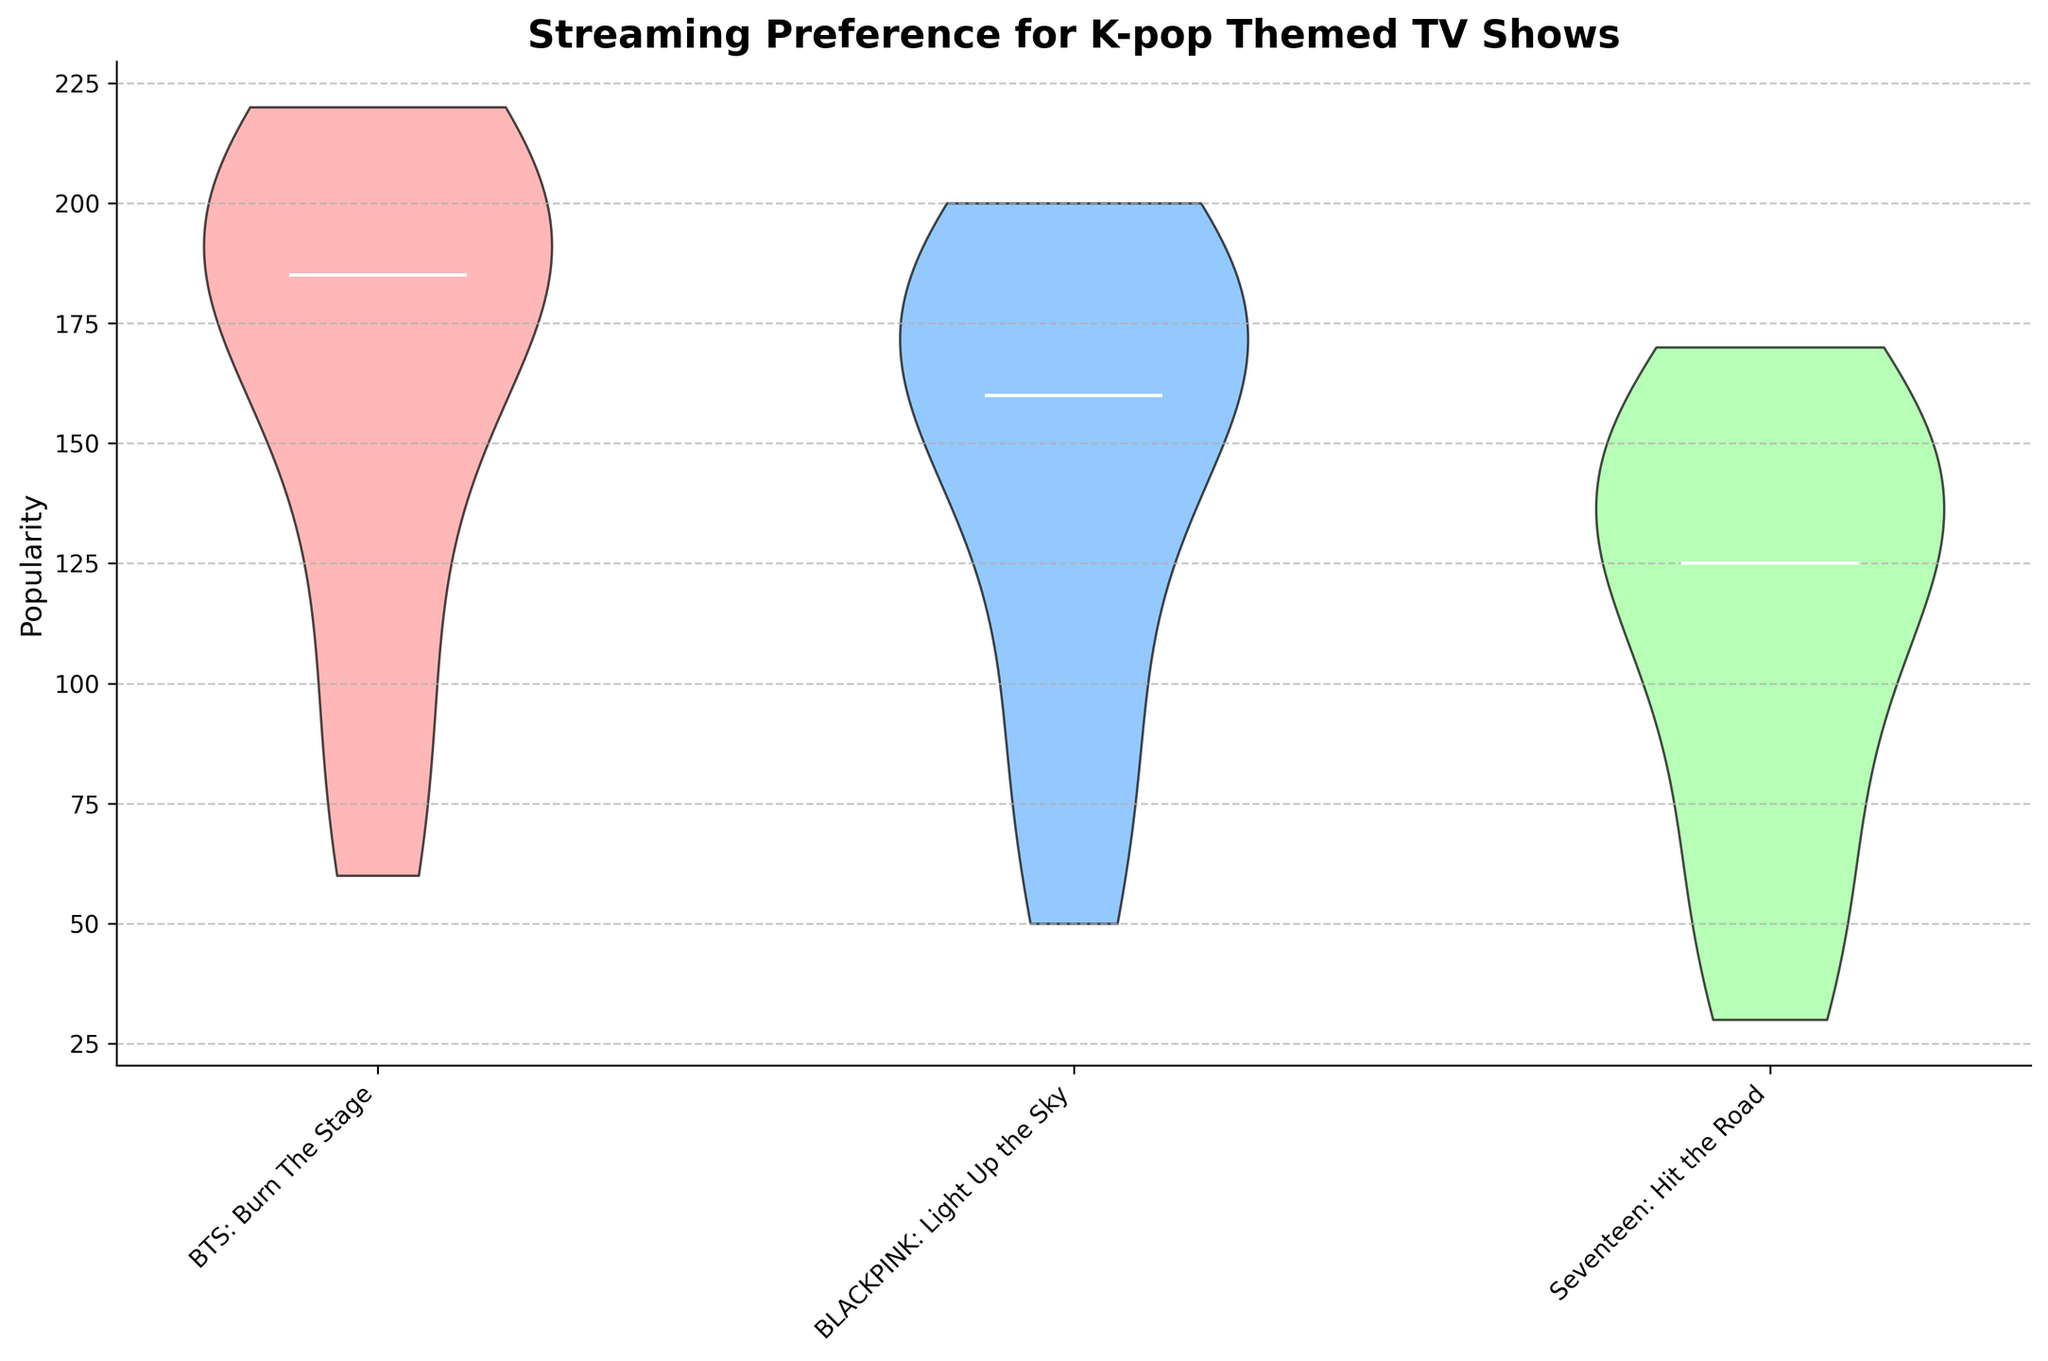what is the title of the figure? The title is located at the top center of the figure. It is descriptive and highlights the subject of the chart, which is the Streaming Preference for K-pop Themed TV Shows.
Answer: Streaming Preference for K-pop Themed TV Shows Which K-pop show appears to have the highest median popularity across the shown time slots? In a violin plot, the median is usually indicated by a distinct line within the shaded area. By comparing the median lines of each K-pop show, we can see that "BTS: Burn The Stage" has the highest median line among the rest.
Answer: BTS: Burn The Stage How does the popularity of "Seventeen: Hit the Road" compare to "BLACKPINK: Light Up the Sky" at their respective least popular time slots? By looking at the narrowest part of the violins which represent lower ends of the popularity distribution, we can see that "Seventeen: Hit the Road" has a minimum lower than "BLACKPINK: Light Up the Sky," indicating "Seventeen: Hit the Road" is less popular at its least popular time slots.
Answer: Seventeen: Hit the Road is less popular What K-pop show displays the widest range of popularity values? The width of the violin plot shows how spread out the data is. By comparing the width of the violins for each show, "BTS: Burn The Stage" displays a wider range in its distribution, thereby having the widest range of popularity values compared to the others.
Answer: BTS: Burn The Stage Which TV show has the narrowest range of popularity values, and what does it indicate about audience preference? The narrowest violin plot indicates the range of popularity spread. "Seventeen: Hit The Road" has the narrowest violin, indicating its popularity values are more concentrated, suggesting a more consistent but smaller audience.
Answer: Seventeen: Hit the Road What can be said about the peak popularity of "BTS: Burn The Stage" from midnight to 4 AM and from 12 PM to 4 PM? By comparing the height (or the most dense part) of the violin plots within these time slots for "BTS: Burn The Stage," the peak popularity appears significantly higher during 12 PM to 4 PM compared to midnight to 4 AM, indicating a higher audience preference during the daytime slot.
Answer: More popular from 12 PM to 4 PM What insight does the violin plot provide about the popularity distribution of "BLACKPINK: Light Up the Sky"? The shape of the violin for "BLACKPINK: Light Up the Sky" shows its popularity distribution. It has a relatively balanced spread with bulges indicating varying popularity, but overall maintains significant interest throughout different time slots compared to "Seventeen: Hit The Road" which has more dip in certain slots.
Answer: Balanced distribution What does the white line within each violin represent and how is it useful? The white line within each violin plot represents the median popularity for each K-pop show. It is useful as it divides the distribution into two equal halves, showing where the middle popularity point lies, giving insights into central tendency in audience preference.
Answer: Median popularity 